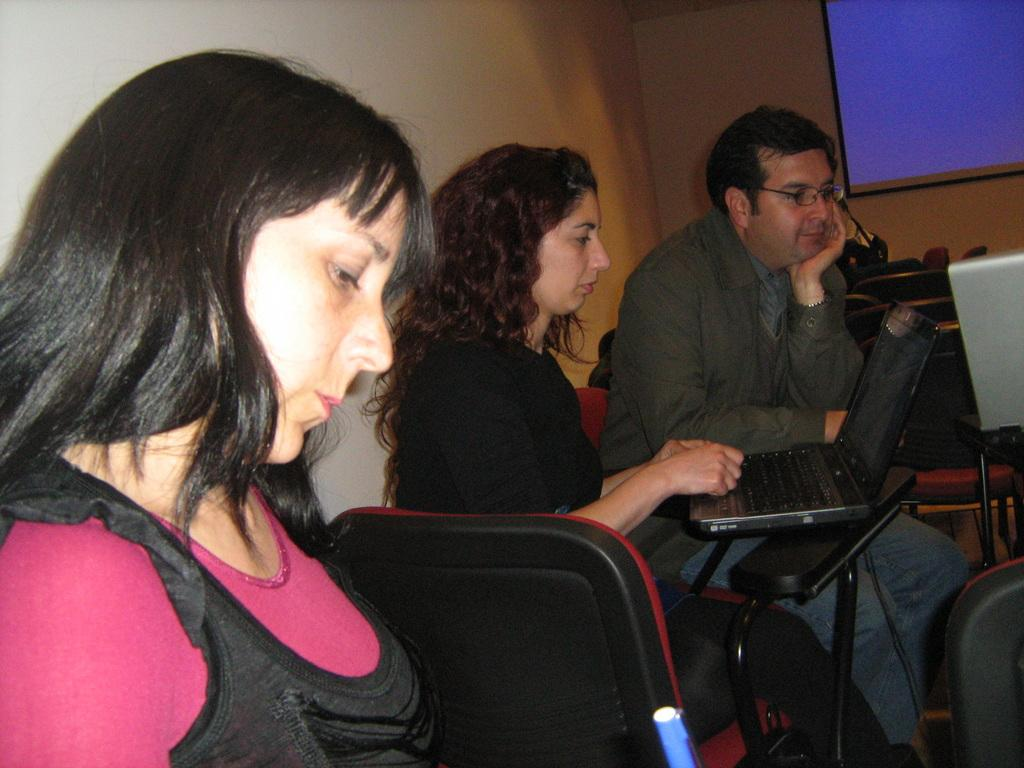How many people are present in the image? There are three people in the image. What objects can be seen in the image? There are chairs and laptops in the image. What is visible in the background of the image? There is a wall and a projector screen in the background of the image. What type of alley can be seen behind the wall in the image? There is no alley present in the image; it only shows a wall and a projector screen in the background. 